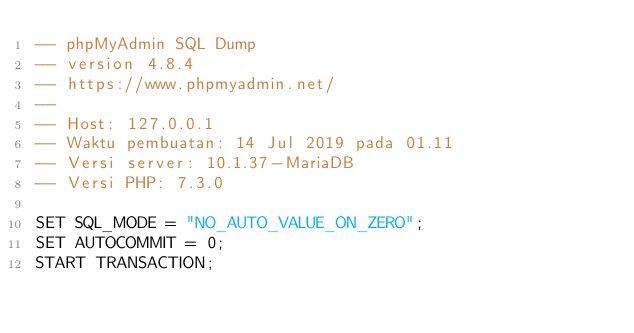Convert code to text. <code><loc_0><loc_0><loc_500><loc_500><_SQL_>-- phpMyAdmin SQL Dump
-- version 4.8.4
-- https://www.phpmyadmin.net/
--
-- Host: 127.0.0.1
-- Waktu pembuatan: 14 Jul 2019 pada 01.11
-- Versi server: 10.1.37-MariaDB
-- Versi PHP: 7.3.0

SET SQL_MODE = "NO_AUTO_VALUE_ON_ZERO";
SET AUTOCOMMIT = 0;
START TRANSACTION;</code> 